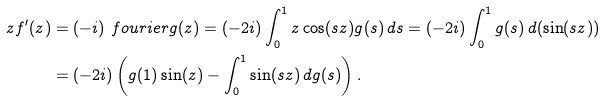Convert formula to latex. <formula><loc_0><loc_0><loc_500><loc_500>z f ^ { \prime } ( z ) & = ( - i ) \ f o u r i e r { g } ( z ) = ( - 2 i ) \int _ { 0 } ^ { 1 } z \cos ( s z ) g ( s ) \, d s = ( - 2 i ) \int _ { 0 } ^ { 1 } g ( s ) \, d ( \sin ( s z ) ) \\ & = ( - 2 i ) \left ( g ( 1 ) \sin ( z ) - \int _ { 0 } ^ { 1 } \sin ( s z ) \, d g ( s ) \right ) .</formula> 